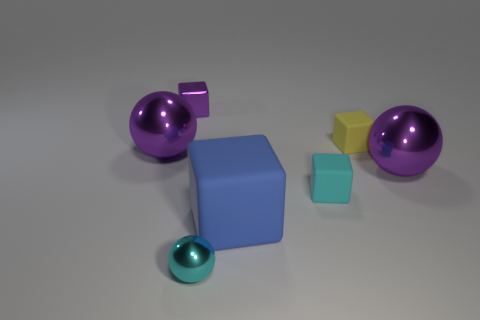There is a purple object that is to the right of the small shiny block; what size is it?
Offer a very short reply. Large. Is the number of large matte objects less than the number of spheres?
Keep it short and to the point. Yes. Are there any small metal objects that have the same color as the tiny sphere?
Make the answer very short. No. What shape is the large object that is both on the left side of the tiny cyan matte object and behind the cyan cube?
Make the answer very short. Sphere. What shape is the tiny metal thing that is behind the purple metallic object to the right of the small purple block?
Your answer should be very brief. Cube. Do the cyan rubber object and the cyan metallic object have the same shape?
Make the answer very short. No. There is a small thing that is the same color as the tiny shiny sphere; what is its material?
Your response must be concise. Rubber. Do the small metal block and the large matte cube have the same color?
Give a very brief answer. No. There is a big sphere to the right of the block that is left of the small cyan metallic object; how many purple metallic spheres are on the left side of it?
Offer a terse response. 1. There is a tiny cyan thing that is made of the same material as the purple cube; what is its shape?
Offer a terse response. Sphere. 